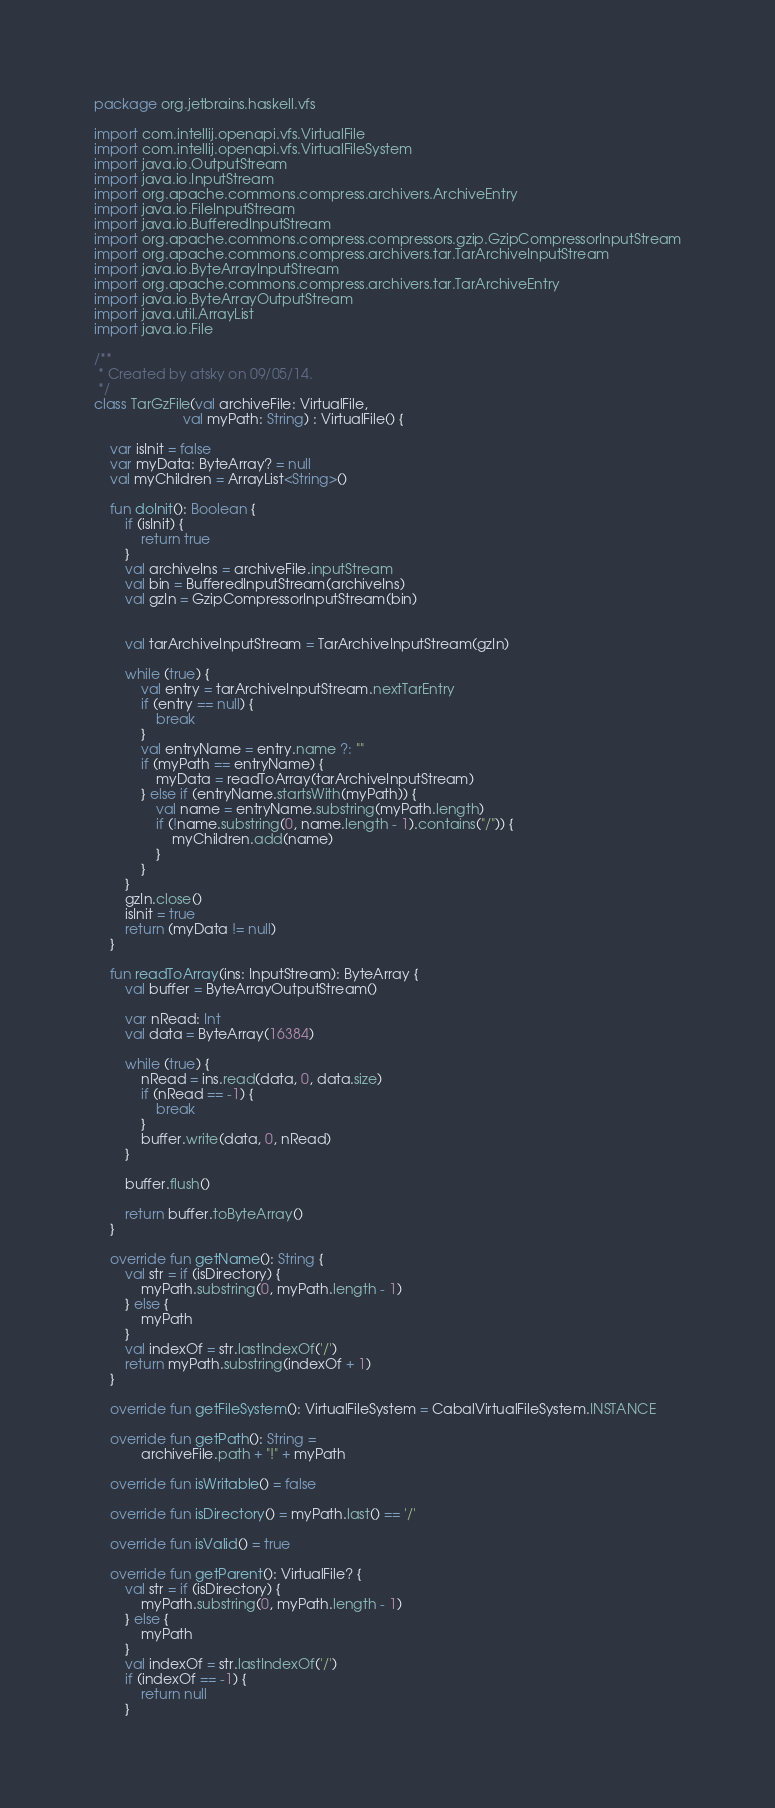Convert code to text. <code><loc_0><loc_0><loc_500><loc_500><_Kotlin_>package org.jetbrains.haskell.vfs

import com.intellij.openapi.vfs.VirtualFile
import com.intellij.openapi.vfs.VirtualFileSystem
import java.io.OutputStream
import java.io.InputStream
import org.apache.commons.compress.archivers.ArchiveEntry
import java.io.FileInputStream
import java.io.BufferedInputStream
import org.apache.commons.compress.compressors.gzip.GzipCompressorInputStream
import org.apache.commons.compress.archivers.tar.TarArchiveInputStream
import java.io.ByteArrayInputStream
import org.apache.commons.compress.archivers.tar.TarArchiveEntry
import java.io.ByteArrayOutputStream
import java.util.ArrayList
import java.io.File

/**
 * Created by atsky on 09/05/14.
 */
class TarGzFile(val archiveFile: VirtualFile,
                       val myPath: String) : VirtualFile() {

    var isInit = false
    var myData: ByteArray? = null
    val myChildren = ArrayList<String>()

    fun doInit(): Boolean {
        if (isInit) {
            return true
        }
        val archiveIns = archiveFile.inputStream
        val bin = BufferedInputStream(archiveIns)
        val gzIn = GzipCompressorInputStream(bin)


        val tarArchiveInputStream = TarArchiveInputStream(gzIn)

        while (true) {
            val entry = tarArchiveInputStream.nextTarEntry
            if (entry == null) {
                break
            }
            val entryName = entry.name ?: ""
            if (myPath == entryName) {
                myData = readToArray(tarArchiveInputStream)
            } else if (entryName.startsWith(myPath)) {
                val name = entryName.substring(myPath.length)
                if (!name.substring(0, name.length - 1).contains("/")) {
                    myChildren.add(name)
                }
            }
        }
        gzIn.close()
        isInit = true
        return (myData != null)
    }

    fun readToArray(ins: InputStream): ByteArray {
        val buffer = ByteArrayOutputStream()

        var nRead: Int
        val data = ByteArray(16384)

        while (true) {
            nRead = ins.read(data, 0, data.size)
            if (nRead == -1) {
                break
            }
            buffer.write(data, 0, nRead)
        }

        buffer.flush()

        return buffer.toByteArray()
    }

    override fun getName(): String {
        val str = if (isDirectory) {
            myPath.substring(0, myPath.length - 1)
        } else {
            myPath
        }
        val indexOf = str.lastIndexOf('/')
        return myPath.substring(indexOf + 1)
    }

    override fun getFileSystem(): VirtualFileSystem = CabalVirtualFileSystem.INSTANCE

    override fun getPath(): String =
            archiveFile.path + "!" + myPath

    override fun isWritable() = false

    override fun isDirectory() = myPath.last() == '/'

    override fun isValid() = true

    override fun getParent(): VirtualFile? {
        val str = if (isDirectory) {
            myPath.substring(0, myPath.length - 1)
        } else {
            myPath
        }
        val indexOf = str.lastIndexOf('/')
        if (indexOf == -1) {
            return null
        }</code> 